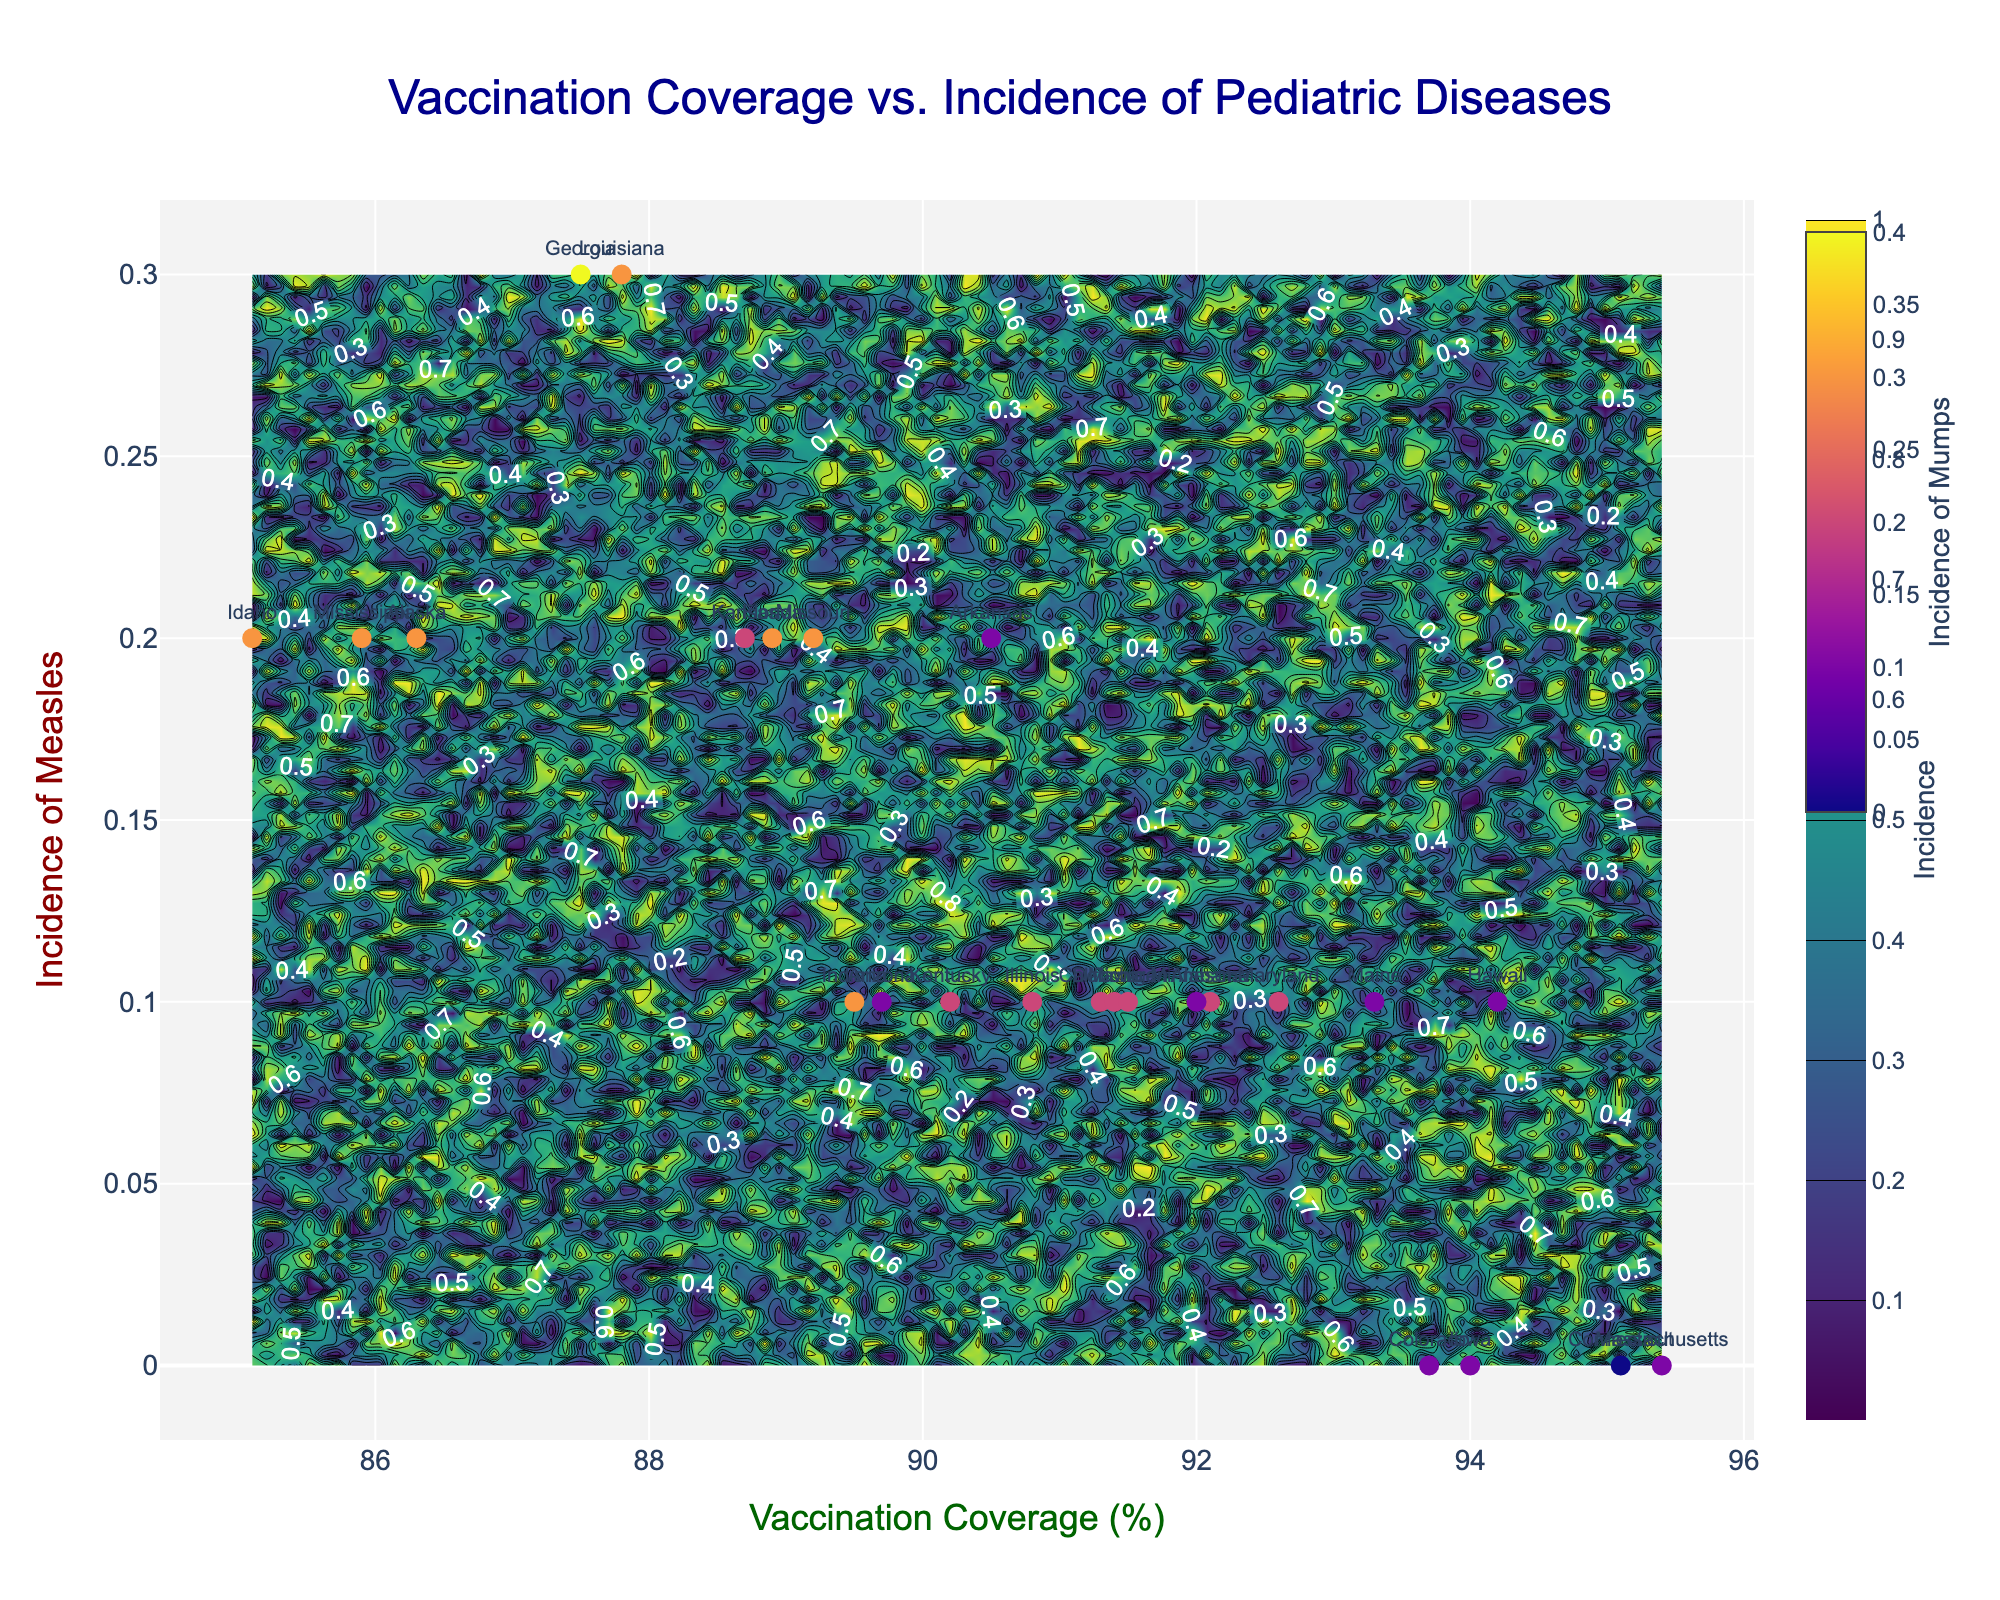What is the title of the figure? The title of a figure is typically located at the top and summarizes the main topic or data presented in the plot. In this case, the title is displayed prominently in a large, dark blue font stating the essence of the visualized data.
Answer: Vaccination Coverage vs. Incidence of Pediatric Diseases What does the x-axis represent? The labels on the x-axis provide the information about what is being measured or presented along the horizontal axis. Here, it denotes the percentage of vaccination coverage.
Answer: Vaccination Coverage (%) What does the y-axis represent? The labels on the y-axis provide what is being measured or presented along the vertical axis. In this figure, it represents the incidence of measles.
Answer: Incidence of Measles What do the different colors on the contour plot signify? Contour plots use colors to represent different ranges of data. The color gradient (in this case 'Viridis' scale) indicates varying incidence levels or densities represented by the contour lines with a colorbar providing the scale legend.
Answer: Different levels of incidence Which state has the highest incidence of mumps? The incidence of mumps is denoted by the color of the markers in the scatter plot. By observing the colorbar on the right labeled 'Incidence of Mumps', the darkest color represents the highest value. In this plot, Georgia has the darkest marker.
Answer: Georgia What is the approximate incidence of measles when the vaccination coverage is around 85%? Locate the x-axis value of approximately 85% and trace vertically up to the contour lines or scatter plot markers reflecting incidence levels of measles, deriving an average or common value observed at this x-coordinate.
Answer: Approximately 0.2 Which states have a vaccination coverage greater than 93%? By noting the x-coordinates greater than 93%, identify all corresponding data points on the scatter plot or labeled states that fit this criteria.
Answer: Colorado, Connecticut, Hawaii, Iowa, Massachusetts Between which vaccination coverage percentages does the incidence of measles show the most variability? Examine the contour plot and scatter plot for intervals on the x-axis where there is a high density or a wide range of colors of contour lines and varied data point positions on the y-axis, indicating high variability in incidences.
Answer: 87% to 90% Is there a trend between higher vaccination coverage and the incidence of measles? Observing the scatter plot markers along the x-axis and noting their corresponding y-axis values, determine if there is a pattern or observable relationship where changes in vaccination coverage correlate with changes in measles incidence.
Answer: Generally, higher vaccination coverage shows lower incidence of measles 